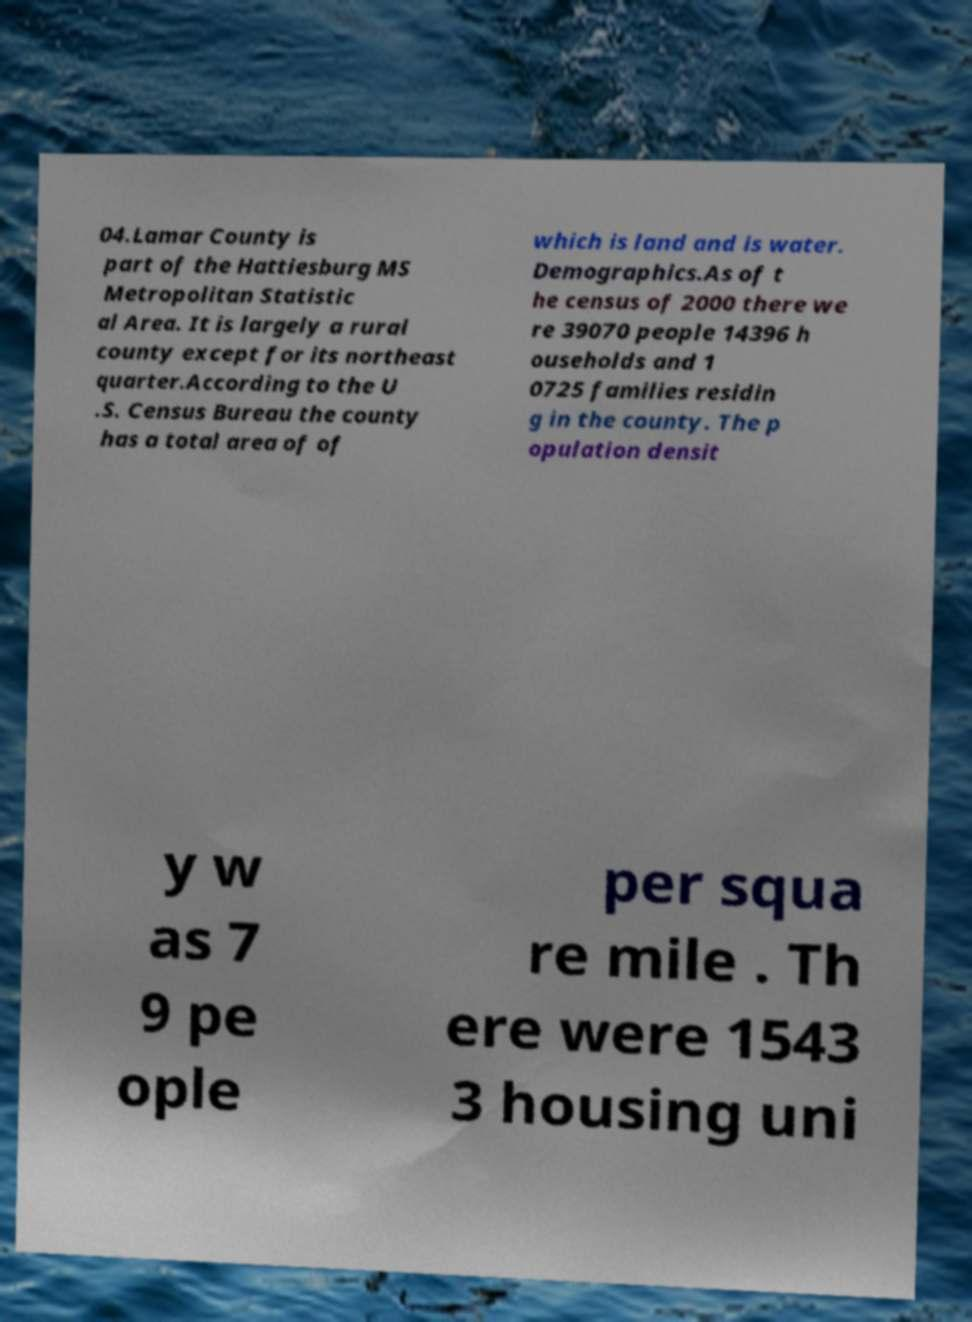Can you accurately transcribe the text from the provided image for me? 04.Lamar County is part of the Hattiesburg MS Metropolitan Statistic al Area. It is largely a rural county except for its northeast quarter.According to the U .S. Census Bureau the county has a total area of of which is land and is water. Demographics.As of t he census of 2000 there we re 39070 people 14396 h ouseholds and 1 0725 families residin g in the county. The p opulation densit y w as 7 9 pe ople per squa re mile . Th ere were 1543 3 housing uni 